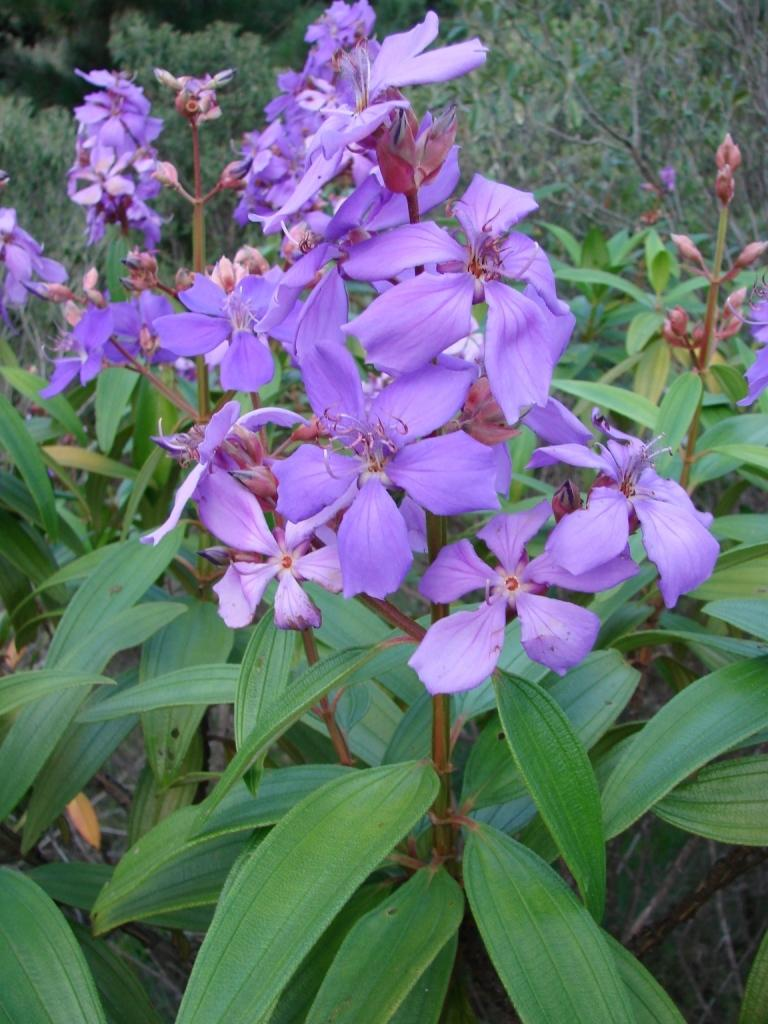What type of vegetation can be seen in the image? There are flowers and plants in the image. Where are the flowers and plants located in the image? The flowers and plants are in the middle of the image. What can be seen in the background of the image? There are trees in the background of the image. How many dogs are taking a vacation in the image? There are no dogs or vacations mentioned or depicted in the image. 